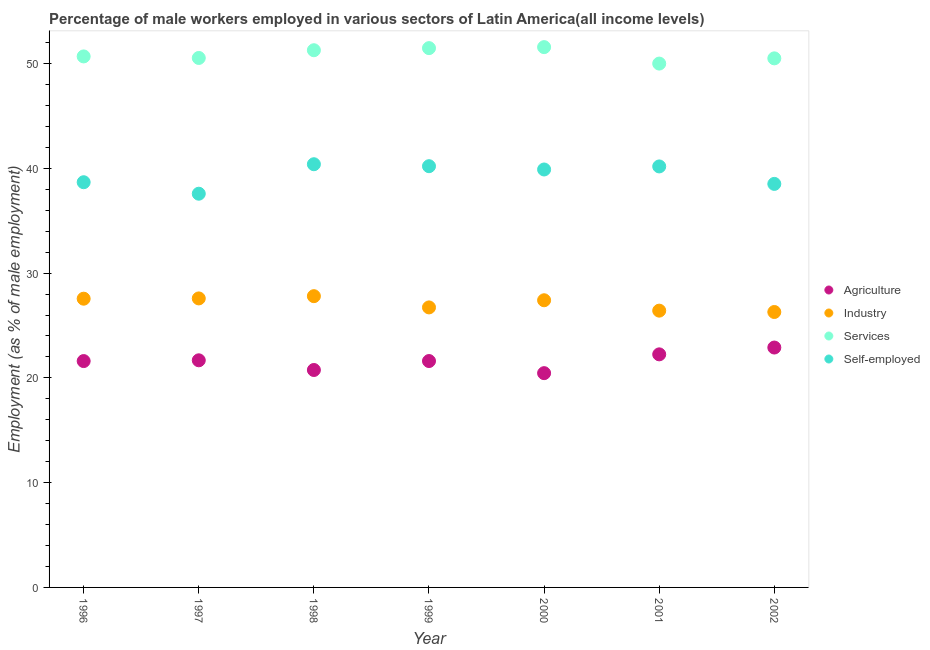How many different coloured dotlines are there?
Make the answer very short. 4. What is the percentage of self employed male workers in 1999?
Offer a terse response. 40.21. Across all years, what is the maximum percentage of male workers in agriculture?
Your answer should be compact. 22.9. Across all years, what is the minimum percentage of self employed male workers?
Provide a succinct answer. 37.58. What is the total percentage of male workers in services in the graph?
Your answer should be compact. 356.05. What is the difference between the percentage of male workers in agriculture in 1996 and that in 1997?
Your answer should be very brief. -0.07. What is the difference between the percentage of male workers in services in 1997 and the percentage of male workers in agriculture in 1999?
Keep it short and to the point. 28.93. What is the average percentage of male workers in services per year?
Your answer should be compact. 50.86. In the year 1998, what is the difference between the percentage of male workers in agriculture and percentage of male workers in industry?
Make the answer very short. -7.05. What is the ratio of the percentage of male workers in industry in 1997 to that in 1999?
Keep it short and to the point. 1.03. Is the percentage of male workers in agriculture in 1999 less than that in 2002?
Provide a short and direct response. Yes. Is the difference between the percentage of self employed male workers in 1997 and 2000 greater than the difference between the percentage of male workers in agriculture in 1997 and 2000?
Your response must be concise. No. What is the difference between the highest and the second highest percentage of male workers in agriculture?
Offer a very short reply. 0.65. What is the difference between the highest and the lowest percentage of male workers in agriculture?
Provide a short and direct response. 2.44. Is the sum of the percentage of male workers in industry in 1997 and 1999 greater than the maximum percentage of male workers in services across all years?
Make the answer very short. Yes. Is it the case that in every year, the sum of the percentage of male workers in agriculture and percentage of male workers in industry is greater than the percentage of male workers in services?
Offer a very short reply. No. How many dotlines are there?
Keep it short and to the point. 4. How many years are there in the graph?
Your answer should be very brief. 7. Does the graph contain any zero values?
Provide a short and direct response. No. Where does the legend appear in the graph?
Keep it short and to the point. Center right. How are the legend labels stacked?
Ensure brevity in your answer.  Vertical. What is the title of the graph?
Provide a succinct answer. Percentage of male workers employed in various sectors of Latin America(all income levels). Does "European Union" appear as one of the legend labels in the graph?
Make the answer very short. No. What is the label or title of the Y-axis?
Provide a short and direct response. Employment (as % of male employment). What is the Employment (as % of male employment) of Agriculture in 1996?
Make the answer very short. 21.61. What is the Employment (as % of male employment) in Industry in 1996?
Provide a succinct answer. 27.56. What is the Employment (as % of male employment) of Services in 1996?
Give a very brief answer. 50.68. What is the Employment (as % of male employment) of Self-employed in 1996?
Ensure brevity in your answer.  38.68. What is the Employment (as % of male employment) of Agriculture in 1997?
Make the answer very short. 21.68. What is the Employment (as % of male employment) in Industry in 1997?
Keep it short and to the point. 27.59. What is the Employment (as % of male employment) of Services in 1997?
Your response must be concise. 50.54. What is the Employment (as % of male employment) of Self-employed in 1997?
Offer a terse response. 37.58. What is the Employment (as % of male employment) of Agriculture in 1998?
Offer a very short reply. 20.75. What is the Employment (as % of male employment) of Industry in 1998?
Offer a terse response. 27.8. What is the Employment (as % of male employment) in Services in 1998?
Give a very brief answer. 51.28. What is the Employment (as % of male employment) of Self-employed in 1998?
Your answer should be very brief. 40.39. What is the Employment (as % of male employment) of Agriculture in 1999?
Provide a succinct answer. 21.61. What is the Employment (as % of male employment) in Industry in 1999?
Provide a short and direct response. 26.73. What is the Employment (as % of male employment) in Services in 1999?
Provide a short and direct response. 51.48. What is the Employment (as % of male employment) of Self-employed in 1999?
Provide a succinct answer. 40.21. What is the Employment (as % of male employment) of Agriculture in 2000?
Offer a terse response. 20.45. What is the Employment (as % of male employment) in Industry in 2000?
Ensure brevity in your answer.  27.41. What is the Employment (as % of male employment) in Services in 2000?
Make the answer very short. 51.57. What is the Employment (as % of male employment) of Self-employed in 2000?
Your response must be concise. 39.89. What is the Employment (as % of male employment) in Agriculture in 2001?
Offer a terse response. 22.25. What is the Employment (as % of male employment) of Industry in 2001?
Keep it short and to the point. 26.42. What is the Employment (as % of male employment) in Services in 2001?
Make the answer very short. 50. What is the Employment (as % of male employment) of Self-employed in 2001?
Give a very brief answer. 40.18. What is the Employment (as % of male employment) in Agriculture in 2002?
Keep it short and to the point. 22.9. What is the Employment (as % of male employment) of Industry in 2002?
Your response must be concise. 26.29. What is the Employment (as % of male employment) in Services in 2002?
Your response must be concise. 50.5. What is the Employment (as % of male employment) in Self-employed in 2002?
Your answer should be compact. 38.52. Across all years, what is the maximum Employment (as % of male employment) in Agriculture?
Offer a terse response. 22.9. Across all years, what is the maximum Employment (as % of male employment) of Industry?
Ensure brevity in your answer.  27.8. Across all years, what is the maximum Employment (as % of male employment) of Services?
Offer a very short reply. 51.57. Across all years, what is the maximum Employment (as % of male employment) in Self-employed?
Your answer should be compact. 40.39. Across all years, what is the minimum Employment (as % of male employment) in Agriculture?
Your response must be concise. 20.45. Across all years, what is the minimum Employment (as % of male employment) of Industry?
Ensure brevity in your answer.  26.29. Across all years, what is the minimum Employment (as % of male employment) in Services?
Offer a very short reply. 50. Across all years, what is the minimum Employment (as % of male employment) of Self-employed?
Ensure brevity in your answer.  37.58. What is the total Employment (as % of male employment) in Agriculture in the graph?
Your answer should be very brief. 151.24. What is the total Employment (as % of male employment) of Industry in the graph?
Give a very brief answer. 189.79. What is the total Employment (as % of male employment) in Services in the graph?
Offer a very short reply. 356.05. What is the total Employment (as % of male employment) of Self-employed in the graph?
Give a very brief answer. 275.45. What is the difference between the Employment (as % of male employment) of Agriculture in 1996 and that in 1997?
Give a very brief answer. -0.07. What is the difference between the Employment (as % of male employment) in Industry in 1996 and that in 1997?
Provide a short and direct response. -0.03. What is the difference between the Employment (as % of male employment) of Services in 1996 and that in 1997?
Make the answer very short. 0.15. What is the difference between the Employment (as % of male employment) in Self-employed in 1996 and that in 1997?
Offer a very short reply. 1.1. What is the difference between the Employment (as % of male employment) of Agriculture in 1996 and that in 1998?
Your response must be concise. 0.85. What is the difference between the Employment (as % of male employment) in Industry in 1996 and that in 1998?
Your response must be concise. -0.24. What is the difference between the Employment (as % of male employment) in Services in 1996 and that in 1998?
Your answer should be compact. -0.59. What is the difference between the Employment (as % of male employment) in Self-employed in 1996 and that in 1998?
Provide a short and direct response. -1.72. What is the difference between the Employment (as % of male employment) of Agriculture in 1996 and that in 1999?
Ensure brevity in your answer.  -0. What is the difference between the Employment (as % of male employment) in Industry in 1996 and that in 1999?
Ensure brevity in your answer.  0.83. What is the difference between the Employment (as % of male employment) in Services in 1996 and that in 1999?
Provide a short and direct response. -0.79. What is the difference between the Employment (as % of male employment) in Self-employed in 1996 and that in 1999?
Ensure brevity in your answer.  -1.53. What is the difference between the Employment (as % of male employment) of Agriculture in 1996 and that in 2000?
Your answer should be very brief. 1.15. What is the difference between the Employment (as % of male employment) of Industry in 1996 and that in 2000?
Your answer should be compact. 0.15. What is the difference between the Employment (as % of male employment) in Services in 1996 and that in 2000?
Make the answer very short. -0.89. What is the difference between the Employment (as % of male employment) in Self-employed in 1996 and that in 2000?
Provide a short and direct response. -1.22. What is the difference between the Employment (as % of male employment) of Agriculture in 1996 and that in 2001?
Provide a short and direct response. -0.64. What is the difference between the Employment (as % of male employment) of Industry in 1996 and that in 2001?
Provide a succinct answer. 1.14. What is the difference between the Employment (as % of male employment) of Services in 1996 and that in 2001?
Provide a short and direct response. 0.68. What is the difference between the Employment (as % of male employment) of Self-employed in 1996 and that in 2001?
Ensure brevity in your answer.  -1.51. What is the difference between the Employment (as % of male employment) in Agriculture in 1996 and that in 2002?
Your answer should be very brief. -1.29. What is the difference between the Employment (as % of male employment) in Industry in 1996 and that in 2002?
Make the answer very short. 1.27. What is the difference between the Employment (as % of male employment) of Services in 1996 and that in 2002?
Give a very brief answer. 0.18. What is the difference between the Employment (as % of male employment) of Self-employed in 1996 and that in 2002?
Provide a succinct answer. 0.16. What is the difference between the Employment (as % of male employment) of Agriculture in 1997 and that in 1998?
Keep it short and to the point. 0.93. What is the difference between the Employment (as % of male employment) in Industry in 1997 and that in 1998?
Ensure brevity in your answer.  -0.21. What is the difference between the Employment (as % of male employment) in Services in 1997 and that in 1998?
Keep it short and to the point. -0.74. What is the difference between the Employment (as % of male employment) of Self-employed in 1997 and that in 1998?
Provide a short and direct response. -2.81. What is the difference between the Employment (as % of male employment) in Agriculture in 1997 and that in 1999?
Provide a short and direct response. 0.07. What is the difference between the Employment (as % of male employment) in Industry in 1997 and that in 1999?
Provide a short and direct response. 0.86. What is the difference between the Employment (as % of male employment) of Services in 1997 and that in 1999?
Give a very brief answer. -0.94. What is the difference between the Employment (as % of male employment) in Self-employed in 1997 and that in 1999?
Give a very brief answer. -2.63. What is the difference between the Employment (as % of male employment) of Agriculture in 1997 and that in 2000?
Make the answer very short. 1.23. What is the difference between the Employment (as % of male employment) of Industry in 1997 and that in 2000?
Offer a terse response. 0.18. What is the difference between the Employment (as % of male employment) in Services in 1997 and that in 2000?
Ensure brevity in your answer.  -1.03. What is the difference between the Employment (as % of male employment) in Self-employed in 1997 and that in 2000?
Ensure brevity in your answer.  -2.31. What is the difference between the Employment (as % of male employment) in Agriculture in 1997 and that in 2001?
Provide a succinct answer. -0.57. What is the difference between the Employment (as % of male employment) of Industry in 1997 and that in 2001?
Give a very brief answer. 1.17. What is the difference between the Employment (as % of male employment) of Services in 1997 and that in 2001?
Make the answer very short. 0.54. What is the difference between the Employment (as % of male employment) of Self-employed in 1997 and that in 2001?
Give a very brief answer. -2.6. What is the difference between the Employment (as % of male employment) in Agriculture in 1997 and that in 2002?
Your response must be concise. -1.22. What is the difference between the Employment (as % of male employment) in Industry in 1997 and that in 2002?
Provide a short and direct response. 1.3. What is the difference between the Employment (as % of male employment) of Services in 1997 and that in 2002?
Offer a very short reply. 0.04. What is the difference between the Employment (as % of male employment) of Self-employed in 1997 and that in 2002?
Your answer should be compact. -0.94. What is the difference between the Employment (as % of male employment) of Agriculture in 1998 and that in 1999?
Your answer should be compact. -0.85. What is the difference between the Employment (as % of male employment) of Industry in 1998 and that in 1999?
Keep it short and to the point. 1.07. What is the difference between the Employment (as % of male employment) of Services in 1998 and that in 1999?
Offer a terse response. -0.2. What is the difference between the Employment (as % of male employment) in Self-employed in 1998 and that in 1999?
Your response must be concise. 0.19. What is the difference between the Employment (as % of male employment) in Agriculture in 1998 and that in 2000?
Ensure brevity in your answer.  0.3. What is the difference between the Employment (as % of male employment) of Industry in 1998 and that in 2000?
Your answer should be very brief. 0.39. What is the difference between the Employment (as % of male employment) in Services in 1998 and that in 2000?
Provide a short and direct response. -0.3. What is the difference between the Employment (as % of male employment) of Self-employed in 1998 and that in 2000?
Make the answer very short. 0.5. What is the difference between the Employment (as % of male employment) in Agriculture in 1998 and that in 2001?
Keep it short and to the point. -1.49. What is the difference between the Employment (as % of male employment) in Industry in 1998 and that in 2001?
Give a very brief answer. 1.38. What is the difference between the Employment (as % of male employment) of Services in 1998 and that in 2001?
Make the answer very short. 1.27. What is the difference between the Employment (as % of male employment) of Self-employed in 1998 and that in 2001?
Provide a short and direct response. 0.21. What is the difference between the Employment (as % of male employment) of Agriculture in 1998 and that in 2002?
Keep it short and to the point. -2.14. What is the difference between the Employment (as % of male employment) of Industry in 1998 and that in 2002?
Your response must be concise. 1.51. What is the difference between the Employment (as % of male employment) in Services in 1998 and that in 2002?
Your answer should be very brief. 0.78. What is the difference between the Employment (as % of male employment) in Self-employed in 1998 and that in 2002?
Give a very brief answer. 1.88. What is the difference between the Employment (as % of male employment) in Agriculture in 1999 and that in 2000?
Offer a terse response. 1.16. What is the difference between the Employment (as % of male employment) in Industry in 1999 and that in 2000?
Provide a short and direct response. -0.68. What is the difference between the Employment (as % of male employment) in Services in 1999 and that in 2000?
Offer a terse response. -0.1. What is the difference between the Employment (as % of male employment) of Self-employed in 1999 and that in 2000?
Your response must be concise. 0.31. What is the difference between the Employment (as % of male employment) in Agriculture in 1999 and that in 2001?
Give a very brief answer. -0.64. What is the difference between the Employment (as % of male employment) in Industry in 1999 and that in 2001?
Your answer should be compact. 0.31. What is the difference between the Employment (as % of male employment) of Services in 1999 and that in 2001?
Your answer should be compact. 1.48. What is the difference between the Employment (as % of male employment) in Self-employed in 1999 and that in 2001?
Offer a very short reply. 0.02. What is the difference between the Employment (as % of male employment) of Agriculture in 1999 and that in 2002?
Offer a very short reply. -1.29. What is the difference between the Employment (as % of male employment) of Industry in 1999 and that in 2002?
Your answer should be compact. 0.44. What is the difference between the Employment (as % of male employment) in Services in 1999 and that in 2002?
Offer a very short reply. 0.98. What is the difference between the Employment (as % of male employment) of Self-employed in 1999 and that in 2002?
Offer a very short reply. 1.69. What is the difference between the Employment (as % of male employment) of Agriculture in 2000 and that in 2001?
Give a very brief answer. -1.79. What is the difference between the Employment (as % of male employment) of Services in 2000 and that in 2001?
Provide a succinct answer. 1.57. What is the difference between the Employment (as % of male employment) in Self-employed in 2000 and that in 2001?
Offer a terse response. -0.29. What is the difference between the Employment (as % of male employment) in Agriculture in 2000 and that in 2002?
Your response must be concise. -2.44. What is the difference between the Employment (as % of male employment) of Industry in 2000 and that in 2002?
Offer a terse response. 1.12. What is the difference between the Employment (as % of male employment) of Services in 2000 and that in 2002?
Your answer should be very brief. 1.07. What is the difference between the Employment (as % of male employment) of Self-employed in 2000 and that in 2002?
Your response must be concise. 1.38. What is the difference between the Employment (as % of male employment) of Agriculture in 2001 and that in 2002?
Your response must be concise. -0.65. What is the difference between the Employment (as % of male employment) of Industry in 2001 and that in 2002?
Offer a very short reply. 0.13. What is the difference between the Employment (as % of male employment) in Services in 2001 and that in 2002?
Your answer should be compact. -0.5. What is the difference between the Employment (as % of male employment) in Self-employed in 2001 and that in 2002?
Make the answer very short. 1.67. What is the difference between the Employment (as % of male employment) of Agriculture in 1996 and the Employment (as % of male employment) of Industry in 1997?
Provide a short and direct response. -5.98. What is the difference between the Employment (as % of male employment) of Agriculture in 1996 and the Employment (as % of male employment) of Services in 1997?
Your answer should be compact. -28.93. What is the difference between the Employment (as % of male employment) of Agriculture in 1996 and the Employment (as % of male employment) of Self-employed in 1997?
Keep it short and to the point. -15.97. What is the difference between the Employment (as % of male employment) of Industry in 1996 and the Employment (as % of male employment) of Services in 1997?
Keep it short and to the point. -22.98. What is the difference between the Employment (as % of male employment) in Industry in 1996 and the Employment (as % of male employment) in Self-employed in 1997?
Offer a terse response. -10.02. What is the difference between the Employment (as % of male employment) of Services in 1996 and the Employment (as % of male employment) of Self-employed in 1997?
Your response must be concise. 13.1. What is the difference between the Employment (as % of male employment) of Agriculture in 1996 and the Employment (as % of male employment) of Industry in 1998?
Make the answer very short. -6.2. What is the difference between the Employment (as % of male employment) in Agriculture in 1996 and the Employment (as % of male employment) in Services in 1998?
Offer a terse response. -29.67. What is the difference between the Employment (as % of male employment) of Agriculture in 1996 and the Employment (as % of male employment) of Self-employed in 1998?
Your answer should be compact. -18.79. What is the difference between the Employment (as % of male employment) in Industry in 1996 and the Employment (as % of male employment) in Services in 1998?
Your answer should be very brief. -23.72. What is the difference between the Employment (as % of male employment) in Industry in 1996 and the Employment (as % of male employment) in Self-employed in 1998?
Your response must be concise. -12.83. What is the difference between the Employment (as % of male employment) of Services in 1996 and the Employment (as % of male employment) of Self-employed in 1998?
Provide a short and direct response. 10.29. What is the difference between the Employment (as % of male employment) in Agriculture in 1996 and the Employment (as % of male employment) in Industry in 1999?
Offer a terse response. -5.12. What is the difference between the Employment (as % of male employment) in Agriculture in 1996 and the Employment (as % of male employment) in Services in 1999?
Offer a very short reply. -29.87. What is the difference between the Employment (as % of male employment) in Agriculture in 1996 and the Employment (as % of male employment) in Self-employed in 1999?
Keep it short and to the point. -18.6. What is the difference between the Employment (as % of male employment) in Industry in 1996 and the Employment (as % of male employment) in Services in 1999?
Your answer should be compact. -23.92. What is the difference between the Employment (as % of male employment) in Industry in 1996 and the Employment (as % of male employment) in Self-employed in 1999?
Your response must be concise. -12.65. What is the difference between the Employment (as % of male employment) in Services in 1996 and the Employment (as % of male employment) in Self-employed in 1999?
Provide a short and direct response. 10.48. What is the difference between the Employment (as % of male employment) in Agriculture in 1996 and the Employment (as % of male employment) in Industry in 2000?
Keep it short and to the point. -5.81. What is the difference between the Employment (as % of male employment) of Agriculture in 1996 and the Employment (as % of male employment) of Services in 2000?
Keep it short and to the point. -29.97. What is the difference between the Employment (as % of male employment) in Agriculture in 1996 and the Employment (as % of male employment) in Self-employed in 2000?
Keep it short and to the point. -18.29. What is the difference between the Employment (as % of male employment) of Industry in 1996 and the Employment (as % of male employment) of Services in 2000?
Provide a succinct answer. -24.01. What is the difference between the Employment (as % of male employment) of Industry in 1996 and the Employment (as % of male employment) of Self-employed in 2000?
Your answer should be compact. -12.33. What is the difference between the Employment (as % of male employment) of Services in 1996 and the Employment (as % of male employment) of Self-employed in 2000?
Provide a succinct answer. 10.79. What is the difference between the Employment (as % of male employment) of Agriculture in 1996 and the Employment (as % of male employment) of Industry in 2001?
Keep it short and to the point. -4.81. What is the difference between the Employment (as % of male employment) in Agriculture in 1996 and the Employment (as % of male employment) in Services in 2001?
Keep it short and to the point. -28.4. What is the difference between the Employment (as % of male employment) of Agriculture in 1996 and the Employment (as % of male employment) of Self-employed in 2001?
Give a very brief answer. -18.58. What is the difference between the Employment (as % of male employment) in Industry in 1996 and the Employment (as % of male employment) in Services in 2001?
Offer a terse response. -22.44. What is the difference between the Employment (as % of male employment) in Industry in 1996 and the Employment (as % of male employment) in Self-employed in 2001?
Your answer should be compact. -12.62. What is the difference between the Employment (as % of male employment) of Services in 1996 and the Employment (as % of male employment) of Self-employed in 2001?
Your answer should be very brief. 10.5. What is the difference between the Employment (as % of male employment) in Agriculture in 1996 and the Employment (as % of male employment) in Industry in 2002?
Make the answer very short. -4.68. What is the difference between the Employment (as % of male employment) in Agriculture in 1996 and the Employment (as % of male employment) in Services in 2002?
Offer a very short reply. -28.89. What is the difference between the Employment (as % of male employment) of Agriculture in 1996 and the Employment (as % of male employment) of Self-employed in 2002?
Your answer should be compact. -16.91. What is the difference between the Employment (as % of male employment) of Industry in 1996 and the Employment (as % of male employment) of Services in 2002?
Provide a short and direct response. -22.94. What is the difference between the Employment (as % of male employment) of Industry in 1996 and the Employment (as % of male employment) of Self-employed in 2002?
Your answer should be compact. -10.96. What is the difference between the Employment (as % of male employment) of Services in 1996 and the Employment (as % of male employment) of Self-employed in 2002?
Provide a short and direct response. 12.17. What is the difference between the Employment (as % of male employment) of Agriculture in 1997 and the Employment (as % of male employment) of Industry in 1998?
Your response must be concise. -6.12. What is the difference between the Employment (as % of male employment) in Agriculture in 1997 and the Employment (as % of male employment) in Services in 1998?
Provide a succinct answer. -29.6. What is the difference between the Employment (as % of male employment) in Agriculture in 1997 and the Employment (as % of male employment) in Self-employed in 1998?
Ensure brevity in your answer.  -18.72. What is the difference between the Employment (as % of male employment) in Industry in 1997 and the Employment (as % of male employment) in Services in 1998?
Offer a very short reply. -23.69. What is the difference between the Employment (as % of male employment) of Industry in 1997 and the Employment (as % of male employment) of Self-employed in 1998?
Your answer should be compact. -12.81. What is the difference between the Employment (as % of male employment) of Services in 1997 and the Employment (as % of male employment) of Self-employed in 1998?
Offer a very short reply. 10.14. What is the difference between the Employment (as % of male employment) in Agriculture in 1997 and the Employment (as % of male employment) in Industry in 1999?
Offer a very short reply. -5.05. What is the difference between the Employment (as % of male employment) in Agriculture in 1997 and the Employment (as % of male employment) in Services in 1999?
Offer a terse response. -29.8. What is the difference between the Employment (as % of male employment) in Agriculture in 1997 and the Employment (as % of male employment) in Self-employed in 1999?
Provide a short and direct response. -18.53. What is the difference between the Employment (as % of male employment) in Industry in 1997 and the Employment (as % of male employment) in Services in 1999?
Offer a very short reply. -23.89. What is the difference between the Employment (as % of male employment) in Industry in 1997 and the Employment (as % of male employment) in Self-employed in 1999?
Provide a short and direct response. -12.62. What is the difference between the Employment (as % of male employment) of Services in 1997 and the Employment (as % of male employment) of Self-employed in 1999?
Your response must be concise. 10.33. What is the difference between the Employment (as % of male employment) of Agriculture in 1997 and the Employment (as % of male employment) of Industry in 2000?
Your answer should be very brief. -5.73. What is the difference between the Employment (as % of male employment) of Agriculture in 1997 and the Employment (as % of male employment) of Services in 2000?
Make the answer very short. -29.89. What is the difference between the Employment (as % of male employment) of Agriculture in 1997 and the Employment (as % of male employment) of Self-employed in 2000?
Provide a succinct answer. -18.21. What is the difference between the Employment (as % of male employment) in Industry in 1997 and the Employment (as % of male employment) in Services in 2000?
Provide a succinct answer. -23.99. What is the difference between the Employment (as % of male employment) of Industry in 1997 and the Employment (as % of male employment) of Self-employed in 2000?
Provide a short and direct response. -12.31. What is the difference between the Employment (as % of male employment) in Services in 1997 and the Employment (as % of male employment) in Self-employed in 2000?
Your response must be concise. 10.65. What is the difference between the Employment (as % of male employment) of Agriculture in 1997 and the Employment (as % of male employment) of Industry in 2001?
Offer a very short reply. -4.74. What is the difference between the Employment (as % of male employment) in Agriculture in 1997 and the Employment (as % of male employment) in Services in 2001?
Make the answer very short. -28.32. What is the difference between the Employment (as % of male employment) in Agriculture in 1997 and the Employment (as % of male employment) in Self-employed in 2001?
Keep it short and to the point. -18.5. What is the difference between the Employment (as % of male employment) in Industry in 1997 and the Employment (as % of male employment) in Services in 2001?
Provide a succinct answer. -22.42. What is the difference between the Employment (as % of male employment) of Industry in 1997 and the Employment (as % of male employment) of Self-employed in 2001?
Your response must be concise. -12.6. What is the difference between the Employment (as % of male employment) in Services in 1997 and the Employment (as % of male employment) in Self-employed in 2001?
Give a very brief answer. 10.35. What is the difference between the Employment (as % of male employment) of Agriculture in 1997 and the Employment (as % of male employment) of Industry in 2002?
Ensure brevity in your answer.  -4.61. What is the difference between the Employment (as % of male employment) in Agriculture in 1997 and the Employment (as % of male employment) in Services in 2002?
Your answer should be compact. -28.82. What is the difference between the Employment (as % of male employment) in Agriculture in 1997 and the Employment (as % of male employment) in Self-employed in 2002?
Offer a terse response. -16.84. What is the difference between the Employment (as % of male employment) of Industry in 1997 and the Employment (as % of male employment) of Services in 2002?
Keep it short and to the point. -22.91. What is the difference between the Employment (as % of male employment) of Industry in 1997 and the Employment (as % of male employment) of Self-employed in 2002?
Your answer should be very brief. -10.93. What is the difference between the Employment (as % of male employment) of Services in 1997 and the Employment (as % of male employment) of Self-employed in 2002?
Make the answer very short. 12.02. What is the difference between the Employment (as % of male employment) in Agriculture in 1998 and the Employment (as % of male employment) in Industry in 1999?
Offer a very short reply. -5.97. What is the difference between the Employment (as % of male employment) of Agriculture in 1998 and the Employment (as % of male employment) of Services in 1999?
Offer a very short reply. -30.72. What is the difference between the Employment (as % of male employment) in Agriculture in 1998 and the Employment (as % of male employment) in Self-employed in 1999?
Offer a terse response. -19.45. What is the difference between the Employment (as % of male employment) in Industry in 1998 and the Employment (as % of male employment) in Services in 1999?
Ensure brevity in your answer.  -23.68. What is the difference between the Employment (as % of male employment) of Industry in 1998 and the Employment (as % of male employment) of Self-employed in 1999?
Provide a short and direct response. -12.41. What is the difference between the Employment (as % of male employment) in Services in 1998 and the Employment (as % of male employment) in Self-employed in 1999?
Provide a succinct answer. 11.07. What is the difference between the Employment (as % of male employment) of Agriculture in 1998 and the Employment (as % of male employment) of Industry in 2000?
Your response must be concise. -6.66. What is the difference between the Employment (as % of male employment) in Agriculture in 1998 and the Employment (as % of male employment) in Services in 2000?
Ensure brevity in your answer.  -30.82. What is the difference between the Employment (as % of male employment) of Agriculture in 1998 and the Employment (as % of male employment) of Self-employed in 2000?
Provide a succinct answer. -19.14. What is the difference between the Employment (as % of male employment) in Industry in 1998 and the Employment (as % of male employment) in Services in 2000?
Offer a very short reply. -23.77. What is the difference between the Employment (as % of male employment) in Industry in 1998 and the Employment (as % of male employment) in Self-employed in 2000?
Provide a short and direct response. -12.09. What is the difference between the Employment (as % of male employment) in Services in 1998 and the Employment (as % of male employment) in Self-employed in 2000?
Your response must be concise. 11.38. What is the difference between the Employment (as % of male employment) in Agriculture in 1998 and the Employment (as % of male employment) in Industry in 2001?
Ensure brevity in your answer.  -5.67. What is the difference between the Employment (as % of male employment) of Agriculture in 1998 and the Employment (as % of male employment) of Services in 2001?
Give a very brief answer. -29.25. What is the difference between the Employment (as % of male employment) of Agriculture in 1998 and the Employment (as % of male employment) of Self-employed in 2001?
Your answer should be very brief. -19.43. What is the difference between the Employment (as % of male employment) of Industry in 1998 and the Employment (as % of male employment) of Services in 2001?
Provide a short and direct response. -22.2. What is the difference between the Employment (as % of male employment) of Industry in 1998 and the Employment (as % of male employment) of Self-employed in 2001?
Provide a succinct answer. -12.38. What is the difference between the Employment (as % of male employment) in Services in 1998 and the Employment (as % of male employment) in Self-employed in 2001?
Make the answer very short. 11.09. What is the difference between the Employment (as % of male employment) in Agriculture in 1998 and the Employment (as % of male employment) in Industry in 2002?
Your answer should be very brief. -5.54. What is the difference between the Employment (as % of male employment) of Agriculture in 1998 and the Employment (as % of male employment) of Services in 2002?
Provide a short and direct response. -29.75. What is the difference between the Employment (as % of male employment) in Agriculture in 1998 and the Employment (as % of male employment) in Self-employed in 2002?
Ensure brevity in your answer.  -17.76. What is the difference between the Employment (as % of male employment) of Industry in 1998 and the Employment (as % of male employment) of Services in 2002?
Provide a short and direct response. -22.7. What is the difference between the Employment (as % of male employment) in Industry in 1998 and the Employment (as % of male employment) in Self-employed in 2002?
Make the answer very short. -10.72. What is the difference between the Employment (as % of male employment) of Services in 1998 and the Employment (as % of male employment) of Self-employed in 2002?
Keep it short and to the point. 12.76. What is the difference between the Employment (as % of male employment) in Agriculture in 1999 and the Employment (as % of male employment) in Industry in 2000?
Your answer should be very brief. -5.8. What is the difference between the Employment (as % of male employment) in Agriculture in 1999 and the Employment (as % of male employment) in Services in 2000?
Provide a succinct answer. -29.96. What is the difference between the Employment (as % of male employment) in Agriculture in 1999 and the Employment (as % of male employment) in Self-employed in 2000?
Your response must be concise. -18.28. What is the difference between the Employment (as % of male employment) of Industry in 1999 and the Employment (as % of male employment) of Services in 2000?
Keep it short and to the point. -24.84. What is the difference between the Employment (as % of male employment) of Industry in 1999 and the Employment (as % of male employment) of Self-employed in 2000?
Your response must be concise. -13.16. What is the difference between the Employment (as % of male employment) of Services in 1999 and the Employment (as % of male employment) of Self-employed in 2000?
Ensure brevity in your answer.  11.58. What is the difference between the Employment (as % of male employment) in Agriculture in 1999 and the Employment (as % of male employment) in Industry in 2001?
Your answer should be very brief. -4.81. What is the difference between the Employment (as % of male employment) of Agriculture in 1999 and the Employment (as % of male employment) of Services in 2001?
Provide a succinct answer. -28.39. What is the difference between the Employment (as % of male employment) in Agriculture in 1999 and the Employment (as % of male employment) in Self-employed in 2001?
Provide a short and direct response. -18.58. What is the difference between the Employment (as % of male employment) in Industry in 1999 and the Employment (as % of male employment) in Services in 2001?
Keep it short and to the point. -23.27. What is the difference between the Employment (as % of male employment) of Industry in 1999 and the Employment (as % of male employment) of Self-employed in 2001?
Your answer should be compact. -13.46. What is the difference between the Employment (as % of male employment) of Services in 1999 and the Employment (as % of male employment) of Self-employed in 2001?
Offer a very short reply. 11.29. What is the difference between the Employment (as % of male employment) in Agriculture in 1999 and the Employment (as % of male employment) in Industry in 2002?
Provide a succinct answer. -4.68. What is the difference between the Employment (as % of male employment) in Agriculture in 1999 and the Employment (as % of male employment) in Services in 2002?
Give a very brief answer. -28.89. What is the difference between the Employment (as % of male employment) of Agriculture in 1999 and the Employment (as % of male employment) of Self-employed in 2002?
Your answer should be very brief. -16.91. What is the difference between the Employment (as % of male employment) in Industry in 1999 and the Employment (as % of male employment) in Services in 2002?
Ensure brevity in your answer.  -23.77. What is the difference between the Employment (as % of male employment) in Industry in 1999 and the Employment (as % of male employment) in Self-employed in 2002?
Offer a terse response. -11.79. What is the difference between the Employment (as % of male employment) of Services in 1999 and the Employment (as % of male employment) of Self-employed in 2002?
Make the answer very short. 12.96. What is the difference between the Employment (as % of male employment) of Agriculture in 2000 and the Employment (as % of male employment) of Industry in 2001?
Provide a succinct answer. -5.97. What is the difference between the Employment (as % of male employment) of Agriculture in 2000 and the Employment (as % of male employment) of Services in 2001?
Ensure brevity in your answer.  -29.55. What is the difference between the Employment (as % of male employment) in Agriculture in 2000 and the Employment (as % of male employment) in Self-employed in 2001?
Your response must be concise. -19.73. What is the difference between the Employment (as % of male employment) of Industry in 2000 and the Employment (as % of male employment) of Services in 2001?
Make the answer very short. -22.59. What is the difference between the Employment (as % of male employment) of Industry in 2000 and the Employment (as % of male employment) of Self-employed in 2001?
Ensure brevity in your answer.  -12.77. What is the difference between the Employment (as % of male employment) in Services in 2000 and the Employment (as % of male employment) in Self-employed in 2001?
Keep it short and to the point. 11.39. What is the difference between the Employment (as % of male employment) in Agriculture in 2000 and the Employment (as % of male employment) in Industry in 2002?
Offer a terse response. -5.84. What is the difference between the Employment (as % of male employment) in Agriculture in 2000 and the Employment (as % of male employment) in Services in 2002?
Offer a very short reply. -30.05. What is the difference between the Employment (as % of male employment) of Agriculture in 2000 and the Employment (as % of male employment) of Self-employed in 2002?
Give a very brief answer. -18.06. What is the difference between the Employment (as % of male employment) of Industry in 2000 and the Employment (as % of male employment) of Services in 2002?
Provide a succinct answer. -23.09. What is the difference between the Employment (as % of male employment) of Industry in 2000 and the Employment (as % of male employment) of Self-employed in 2002?
Give a very brief answer. -11.11. What is the difference between the Employment (as % of male employment) in Services in 2000 and the Employment (as % of male employment) in Self-employed in 2002?
Provide a short and direct response. 13.05. What is the difference between the Employment (as % of male employment) of Agriculture in 2001 and the Employment (as % of male employment) of Industry in 2002?
Your answer should be compact. -4.04. What is the difference between the Employment (as % of male employment) in Agriculture in 2001 and the Employment (as % of male employment) in Services in 2002?
Provide a succinct answer. -28.25. What is the difference between the Employment (as % of male employment) in Agriculture in 2001 and the Employment (as % of male employment) in Self-employed in 2002?
Give a very brief answer. -16.27. What is the difference between the Employment (as % of male employment) in Industry in 2001 and the Employment (as % of male employment) in Services in 2002?
Ensure brevity in your answer.  -24.08. What is the difference between the Employment (as % of male employment) of Industry in 2001 and the Employment (as % of male employment) of Self-employed in 2002?
Keep it short and to the point. -12.1. What is the difference between the Employment (as % of male employment) of Services in 2001 and the Employment (as % of male employment) of Self-employed in 2002?
Offer a terse response. 11.48. What is the average Employment (as % of male employment) of Agriculture per year?
Ensure brevity in your answer.  21.61. What is the average Employment (as % of male employment) in Industry per year?
Your answer should be very brief. 27.11. What is the average Employment (as % of male employment) in Services per year?
Your response must be concise. 50.86. What is the average Employment (as % of male employment) in Self-employed per year?
Your response must be concise. 39.35. In the year 1996, what is the difference between the Employment (as % of male employment) of Agriculture and Employment (as % of male employment) of Industry?
Ensure brevity in your answer.  -5.95. In the year 1996, what is the difference between the Employment (as % of male employment) in Agriculture and Employment (as % of male employment) in Services?
Your response must be concise. -29.08. In the year 1996, what is the difference between the Employment (as % of male employment) of Agriculture and Employment (as % of male employment) of Self-employed?
Offer a very short reply. -17.07. In the year 1996, what is the difference between the Employment (as % of male employment) of Industry and Employment (as % of male employment) of Services?
Provide a succinct answer. -23.12. In the year 1996, what is the difference between the Employment (as % of male employment) in Industry and Employment (as % of male employment) in Self-employed?
Give a very brief answer. -11.12. In the year 1996, what is the difference between the Employment (as % of male employment) of Services and Employment (as % of male employment) of Self-employed?
Offer a terse response. 12.01. In the year 1997, what is the difference between the Employment (as % of male employment) of Agriculture and Employment (as % of male employment) of Industry?
Your answer should be very brief. -5.91. In the year 1997, what is the difference between the Employment (as % of male employment) in Agriculture and Employment (as % of male employment) in Services?
Make the answer very short. -28.86. In the year 1997, what is the difference between the Employment (as % of male employment) in Agriculture and Employment (as % of male employment) in Self-employed?
Make the answer very short. -15.9. In the year 1997, what is the difference between the Employment (as % of male employment) in Industry and Employment (as % of male employment) in Services?
Your answer should be very brief. -22.95. In the year 1997, what is the difference between the Employment (as % of male employment) in Industry and Employment (as % of male employment) in Self-employed?
Offer a very short reply. -9.99. In the year 1997, what is the difference between the Employment (as % of male employment) of Services and Employment (as % of male employment) of Self-employed?
Provide a succinct answer. 12.96. In the year 1998, what is the difference between the Employment (as % of male employment) of Agriculture and Employment (as % of male employment) of Industry?
Make the answer very short. -7.05. In the year 1998, what is the difference between the Employment (as % of male employment) of Agriculture and Employment (as % of male employment) of Services?
Your answer should be very brief. -30.52. In the year 1998, what is the difference between the Employment (as % of male employment) of Agriculture and Employment (as % of male employment) of Self-employed?
Offer a terse response. -19.64. In the year 1998, what is the difference between the Employment (as % of male employment) in Industry and Employment (as % of male employment) in Services?
Provide a short and direct response. -23.48. In the year 1998, what is the difference between the Employment (as % of male employment) in Industry and Employment (as % of male employment) in Self-employed?
Provide a succinct answer. -12.59. In the year 1998, what is the difference between the Employment (as % of male employment) of Services and Employment (as % of male employment) of Self-employed?
Your answer should be compact. 10.88. In the year 1999, what is the difference between the Employment (as % of male employment) of Agriculture and Employment (as % of male employment) of Industry?
Make the answer very short. -5.12. In the year 1999, what is the difference between the Employment (as % of male employment) of Agriculture and Employment (as % of male employment) of Services?
Keep it short and to the point. -29.87. In the year 1999, what is the difference between the Employment (as % of male employment) of Agriculture and Employment (as % of male employment) of Self-employed?
Give a very brief answer. -18.6. In the year 1999, what is the difference between the Employment (as % of male employment) of Industry and Employment (as % of male employment) of Services?
Provide a short and direct response. -24.75. In the year 1999, what is the difference between the Employment (as % of male employment) in Industry and Employment (as % of male employment) in Self-employed?
Make the answer very short. -13.48. In the year 1999, what is the difference between the Employment (as % of male employment) of Services and Employment (as % of male employment) of Self-employed?
Your response must be concise. 11.27. In the year 2000, what is the difference between the Employment (as % of male employment) of Agriculture and Employment (as % of male employment) of Industry?
Your answer should be very brief. -6.96. In the year 2000, what is the difference between the Employment (as % of male employment) of Agriculture and Employment (as % of male employment) of Services?
Offer a very short reply. -31.12. In the year 2000, what is the difference between the Employment (as % of male employment) of Agriculture and Employment (as % of male employment) of Self-employed?
Provide a succinct answer. -19.44. In the year 2000, what is the difference between the Employment (as % of male employment) in Industry and Employment (as % of male employment) in Services?
Keep it short and to the point. -24.16. In the year 2000, what is the difference between the Employment (as % of male employment) in Industry and Employment (as % of male employment) in Self-employed?
Give a very brief answer. -12.48. In the year 2000, what is the difference between the Employment (as % of male employment) in Services and Employment (as % of male employment) in Self-employed?
Offer a very short reply. 11.68. In the year 2001, what is the difference between the Employment (as % of male employment) of Agriculture and Employment (as % of male employment) of Industry?
Offer a terse response. -4.17. In the year 2001, what is the difference between the Employment (as % of male employment) of Agriculture and Employment (as % of male employment) of Services?
Keep it short and to the point. -27.75. In the year 2001, what is the difference between the Employment (as % of male employment) of Agriculture and Employment (as % of male employment) of Self-employed?
Your answer should be very brief. -17.94. In the year 2001, what is the difference between the Employment (as % of male employment) in Industry and Employment (as % of male employment) in Services?
Keep it short and to the point. -23.58. In the year 2001, what is the difference between the Employment (as % of male employment) of Industry and Employment (as % of male employment) of Self-employed?
Ensure brevity in your answer.  -13.76. In the year 2001, what is the difference between the Employment (as % of male employment) in Services and Employment (as % of male employment) in Self-employed?
Offer a terse response. 9.82. In the year 2002, what is the difference between the Employment (as % of male employment) of Agriculture and Employment (as % of male employment) of Industry?
Your answer should be very brief. -3.39. In the year 2002, what is the difference between the Employment (as % of male employment) of Agriculture and Employment (as % of male employment) of Services?
Your answer should be very brief. -27.6. In the year 2002, what is the difference between the Employment (as % of male employment) in Agriculture and Employment (as % of male employment) in Self-employed?
Ensure brevity in your answer.  -15.62. In the year 2002, what is the difference between the Employment (as % of male employment) in Industry and Employment (as % of male employment) in Services?
Ensure brevity in your answer.  -24.21. In the year 2002, what is the difference between the Employment (as % of male employment) of Industry and Employment (as % of male employment) of Self-employed?
Your response must be concise. -12.23. In the year 2002, what is the difference between the Employment (as % of male employment) of Services and Employment (as % of male employment) of Self-employed?
Give a very brief answer. 11.98. What is the ratio of the Employment (as % of male employment) of Agriculture in 1996 to that in 1997?
Give a very brief answer. 1. What is the ratio of the Employment (as % of male employment) in Industry in 1996 to that in 1997?
Your answer should be very brief. 1. What is the ratio of the Employment (as % of male employment) in Self-employed in 1996 to that in 1997?
Provide a succinct answer. 1.03. What is the ratio of the Employment (as % of male employment) in Agriculture in 1996 to that in 1998?
Provide a succinct answer. 1.04. What is the ratio of the Employment (as % of male employment) of Industry in 1996 to that in 1998?
Ensure brevity in your answer.  0.99. What is the ratio of the Employment (as % of male employment) of Self-employed in 1996 to that in 1998?
Ensure brevity in your answer.  0.96. What is the ratio of the Employment (as % of male employment) of Industry in 1996 to that in 1999?
Offer a terse response. 1.03. What is the ratio of the Employment (as % of male employment) in Services in 1996 to that in 1999?
Ensure brevity in your answer.  0.98. What is the ratio of the Employment (as % of male employment) of Self-employed in 1996 to that in 1999?
Give a very brief answer. 0.96. What is the ratio of the Employment (as % of male employment) in Agriculture in 1996 to that in 2000?
Give a very brief answer. 1.06. What is the ratio of the Employment (as % of male employment) in Industry in 1996 to that in 2000?
Make the answer very short. 1.01. What is the ratio of the Employment (as % of male employment) of Services in 1996 to that in 2000?
Give a very brief answer. 0.98. What is the ratio of the Employment (as % of male employment) of Self-employed in 1996 to that in 2000?
Ensure brevity in your answer.  0.97. What is the ratio of the Employment (as % of male employment) of Agriculture in 1996 to that in 2001?
Make the answer very short. 0.97. What is the ratio of the Employment (as % of male employment) in Industry in 1996 to that in 2001?
Make the answer very short. 1.04. What is the ratio of the Employment (as % of male employment) of Services in 1996 to that in 2001?
Provide a short and direct response. 1.01. What is the ratio of the Employment (as % of male employment) in Self-employed in 1996 to that in 2001?
Keep it short and to the point. 0.96. What is the ratio of the Employment (as % of male employment) in Agriculture in 1996 to that in 2002?
Provide a short and direct response. 0.94. What is the ratio of the Employment (as % of male employment) of Industry in 1996 to that in 2002?
Your response must be concise. 1.05. What is the ratio of the Employment (as % of male employment) in Self-employed in 1996 to that in 2002?
Provide a succinct answer. 1. What is the ratio of the Employment (as % of male employment) of Agriculture in 1997 to that in 1998?
Offer a terse response. 1.04. What is the ratio of the Employment (as % of male employment) in Services in 1997 to that in 1998?
Your response must be concise. 0.99. What is the ratio of the Employment (as % of male employment) of Self-employed in 1997 to that in 1998?
Provide a short and direct response. 0.93. What is the ratio of the Employment (as % of male employment) in Agriculture in 1997 to that in 1999?
Your answer should be very brief. 1. What is the ratio of the Employment (as % of male employment) in Industry in 1997 to that in 1999?
Ensure brevity in your answer.  1.03. What is the ratio of the Employment (as % of male employment) of Services in 1997 to that in 1999?
Offer a terse response. 0.98. What is the ratio of the Employment (as % of male employment) in Self-employed in 1997 to that in 1999?
Provide a short and direct response. 0.93. What is the ratio of the Employment (as % of male employment) of Agriculture in 1997 to that in 2000?
Offer a terse response. 1.06. What is the ratio of the Employment (as % of male employment) in Industry in 1997 to that in 2000?
Ensure brevity in your answer.  1.01. What is the ratio of the Employment (as % of male employment) of Self-employed in 1997 to that in 2000?
Offer a very short reply. 0.94. What is the ratio of the Employment (as % of male employment) of Agriculture in 1997 to that in 2001?
Ensure brevity in your answer.  0.97. What is the ratio of the Employment (as % of male employment) of Industry in 1997 to that in 2001?
Keep it short and to the point. 1.04. What is the ratio of the Employment (as % of male employment) of Services in 1997 to that in 2001?
Your response must be concise. 1.01. What is the ratio of the Employment (as % of male employment) in Self-employed in 1997 to that in 2001?
Offer a terse response. 0.94. What is the ratio of the Employment (as % of male employment) of Agriculture in 1997 to that in 2002?
Ensure brevity in your answer.  0.95. What is the ratio of the Employment (as % of male employment) of Industry in 1997 to that in 2002?
Your response must be concise. 1.05. What is the ratio of the Employment (as % of male employment) of Self-employed in 1997 to that in 2002?
Your answer should be very brief. 0.98. What is the ratio of the Employment (as % of male employment) in Agriculture in 1998 to that in 1999?
Your answer should be compact. 0.96. What is the ratio of the Employment (as % of male employment) in Industry in 1998 to that in 1999?
Ensure brevity in your answer.  1.04. What is the ratio of the Employment (as % of male employment) of Services in 1998 to that in 1999?
Offer a very short reply. 1. What is the ratio of the Employment (as % of male employment) of Agriculture in 1998 to that in 2000?
Keep it short and to the point. 1.01. What is the ratio of the Employment (as % of male employment) in Industry in 1998 to that in 2000?
Provide a short and direct response. 1.01. What is the ratio of the Employment (as % of male employment) in Self-employed in 1998 to that in 2000?
Make the answer very short. 1.01. What is the ratio of the Employment (as % of male employment) of Agriculture in 1998 to that in 2001?
Your response must be concise. 0.93. What is the ratio of the Employment (as % of male employment) of Industry in 1998 to that in 2001?
Make the answer very short. 1.05. What is the ratio of the Employment (as % of male employment) in Services in 1998 to that in 2001?
Provide a short and direct response. 1.03. What is the ratio of the Employment (as % of male employment) in Agriculture in 1998 to that in 2002?
Provide a short and direct response. 0.91. What is the ratio of the Employment (as % of male employment) of Industry in 1998 to that in 2002?
Offer a very short reply. 1.06. What is the ratio of the Employment (as % of male employment) of Services in 1998 to that in 2002?
Ensure brevity in your answer.  1.02. What is the ratio of the Employment (as % of male employment) in Self-employed in 1998 to that in 2002?
Give a very brief answer. 1.05. What is the ratio of the Employment (as % of male employment) of Agriculture in 1999 to that in 2000?
Offer a very short reply. 1.06. What is the ratio of the Employment (as % of male employment) of Industry in 1999 to that in 2000?
Give a very brief answer. 0.98. What is the ratio of the Employment (as % of male employment) in Self-employed in 1999 to that in 2000?
Make the answer very short. 1.01. What is the ratio of the Employment (as % of male employment) in Agriculture in 1999 to that in 2001?
Offer a terse response. 0.97. What is the ratio of the Employment (as % of male employment) of Industry in 1999 to that in 2001?
Your answer should be compact. 1.01. What is the ratio of the Employment (as % of male employment) in Services in 1999 to that in 2001?
Make the answer very short. 1.03. What is the ratio of the Employment (as % of male employment) of Self-employed in 1999 to that in 2001?
Keep it short and to the point. 1. What is the ratio of the Employment (as % of male employment) in Agriculture in 1999 to that in 2002?
Ensure brevity in your answer.  0.94. What is the ratio of the Employment (as % of male employment) in Industry in 1999 to that in 2002?
Your response must be concise. 1.02. What is the ratio of the Employment (as % of male employment) in Services in 1999 to that in 2002?
Keep it short and to the point. 1.02. What is the ratio of the Employment (as % of male employment) of Self-employed in 1999 to that in 2002?
Your answer should be compact. 1.04. What is the ratio of the Employment (as % of male employment) in Agriculture in 2000 to that in 2001?
Your answer should be compact. 0.92. What is the ratio of the Employment (as % of male employment) in Industry in 2000 to that in 2001?
Provide a succinct answer. 1.04. What is the ratio of the Employment (as % of male employment) in Services in 2000 to that in 2001?
Keep it short and to the point. 1.03. What is the ratio of the Employment (as % of male employment) of Agriculture in 2000 to that in 2002?
Offer a very short reply. 0.89. What is the ratio of the Employment (as % of male employment) in Industry in 2000 to that in 2002?
Provide a succinct answer. 1.04. What is the ratio of the Employment (as % of male employment) in Services in 2000 to that in 2002?
Keep it short and to the point. 1.02. What is the ratio of the Employment (as % of male employment) in Self-employed in 2000 to that in 2002?
Provide a succinct answer. 1.04. What is the ratio of the Employment (as % of male employment) of Agriculture in 2001 to that in 2002?
Your answer should be very brief. 0.97. What is the ratio of the Employment (as % of male employment) of Self-employed in 2001 to that in 2002?
Make the answer very short. 1.04. What is the difference between the highest and the second highest Employment (as % of male employment) in Agriculture?
Make the answer very short. 0.65. What is the difference between the highest and the second highest Employment (as % of male employment) of Industry?
Provide a short and direct response. 0.21. What is the difference between the highest and the second highest Employment (as % of male employment) in Services?
Offer a terse response. 0.1. What is the difference between the highest and the second highest Employment (as % of male employment) in Self-employed?
Give a very brief answer. 0.19. What is the difference between the highest and the lowest Employment (as % of male employment) in Agriculture?
Offer a very short reply. 2.44. What is the difference between the highest and the lowest Employment (as % of male employment) in Industry?
Your answer should be compact. 1.51. What is the difference between the highest and the lowest Employment (as % of male employment) of Services?
Ensure brevity in your answer.  1.57. What is the difference between the highest and the lowest Employment (as % of male employment) in Self-employed?
Provide a succinct answer. 2.81. 